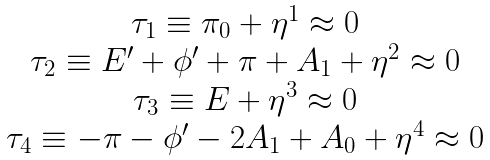<formula> <loc_0><loc_0><loc_500><loc_500>\begin{array} { c } \tau _ { 1 } \equiv \pi _ { 0 } + \eta ^ { 1 } \approx 0 \\ \tau _ { 2 } \equiv E ^ { \prime } + \phi ^ { \prime } + \pi + A _ { 1 } + \eta ^ { 2 } \approx 0 \\ \tau _ { 3 } \equiv E + \eta ^ { 3 } \approx 0 \\ \tau _ { 4 } \equiv - \pi - \phi ^ { \prime } - 2 A _ { 1 } + A _ { 0 } + \eta ^ { 4 } \approx 0 \end{array}</formula> 